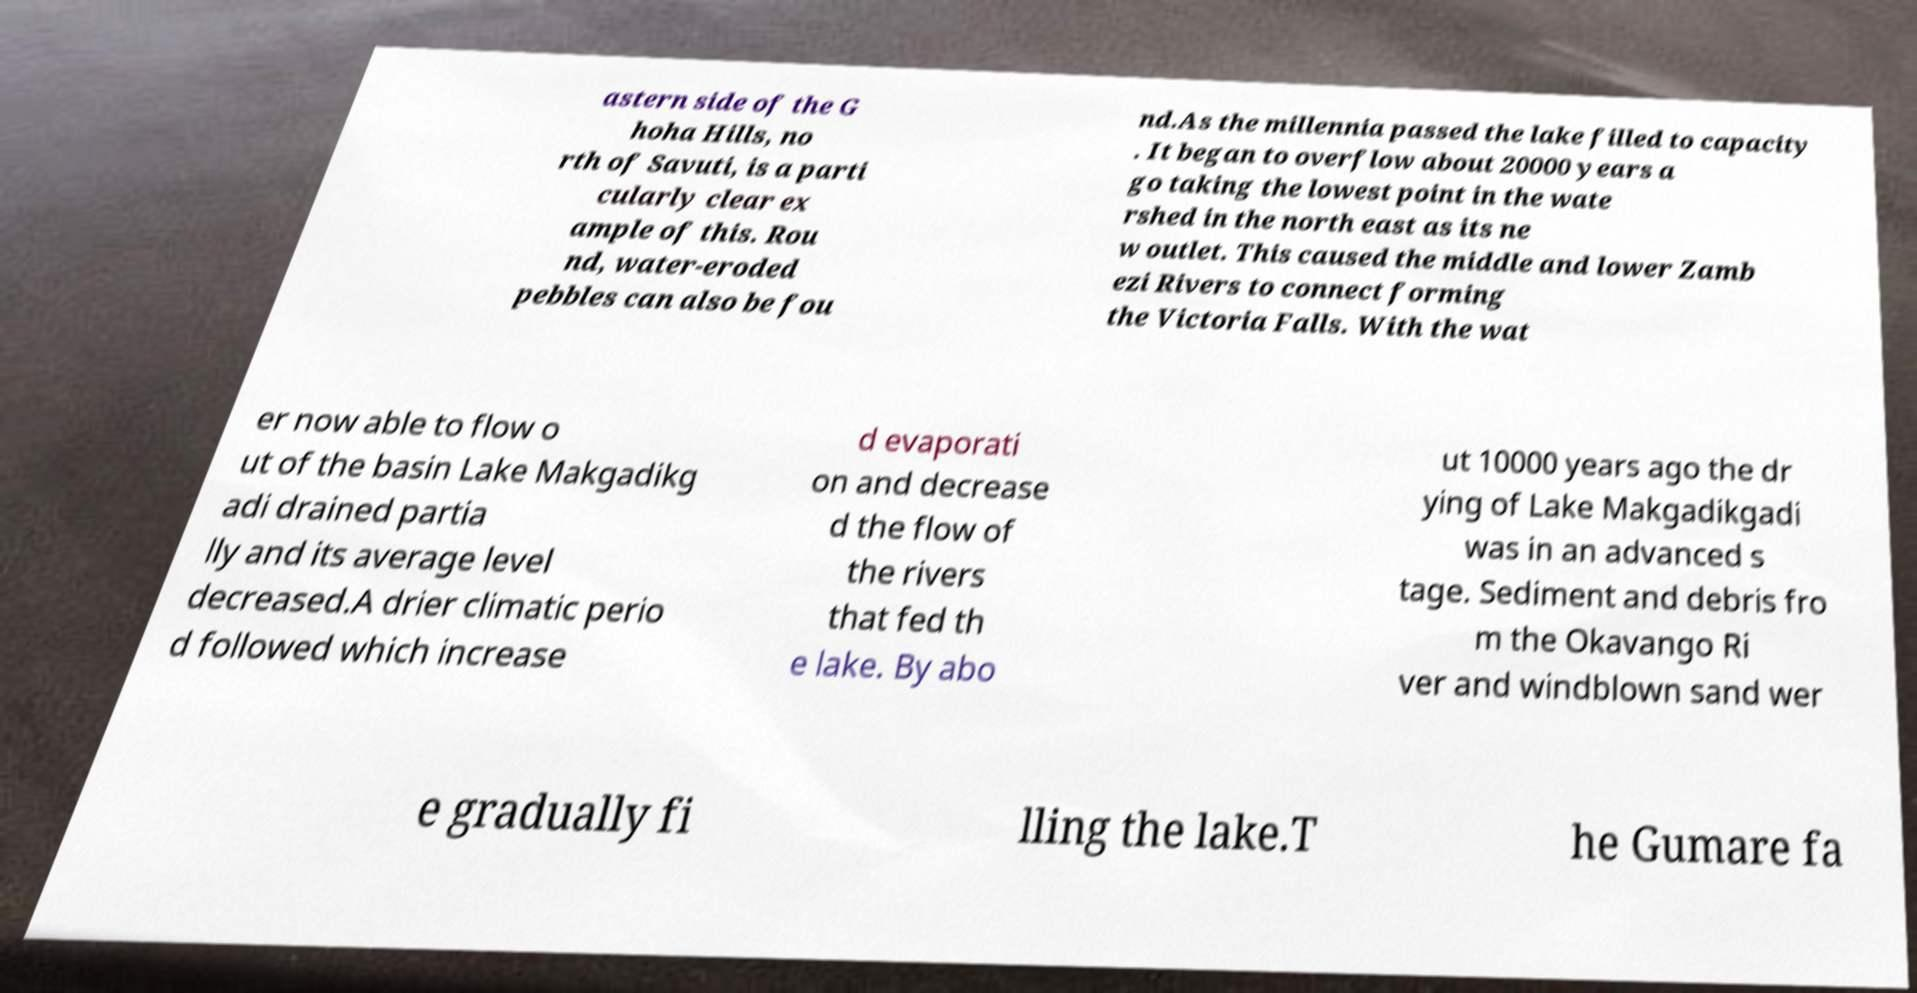Could you assist in decoding the text presented in this image and type it out clearly? astern side of the G hoha Hills, no rth of Savuti, is a parti cularly clear ex ample of this. Rou nd, water-eroded pebbles can also be fou nd.As the millennia passed the lake filled to capacity . It began to overflow about 20000 years a go taking the lowest point in the wate rshed in the north east as its ne w outlet. This caused the middle and lower Zamb ezi Rivers to connect forming the Victoria Falls. With the wat er now able to flow o ut of the basin Lake Makgadikg adi drained partia lly and its average level decreased.A drier climatic perio d followed which increase d evaporati on and decrease d the flow of the rivers that fed th e lake. By abo ut 10000 years ago the dr ying of Lake Makgadikgadi was in an advanced s tage. Sediment and debris fro m the Okavango Ri ver and windblown sand wer e gradually fi lling the lake.T he Gumare fa 